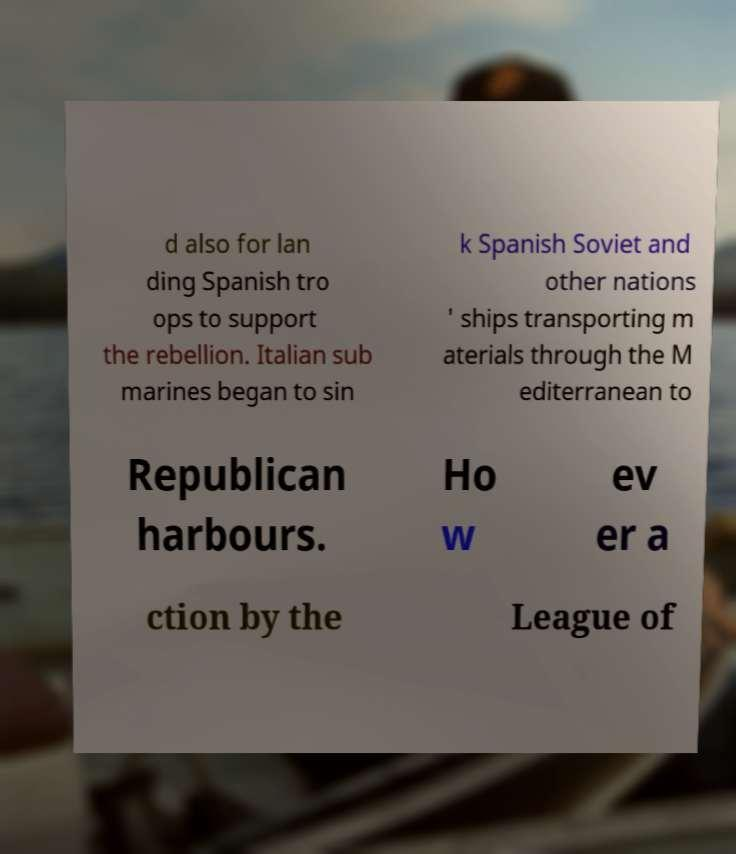Could you extract and type out the text from this image? d also for lan ding Spanish tro ops to support the rebellion. Italian sub marines began to sin k Spanish Soviet and other nations ' ships transporting m aterials through the M editerranean to Republican harbours. Ho w ev er a ction by the League of 